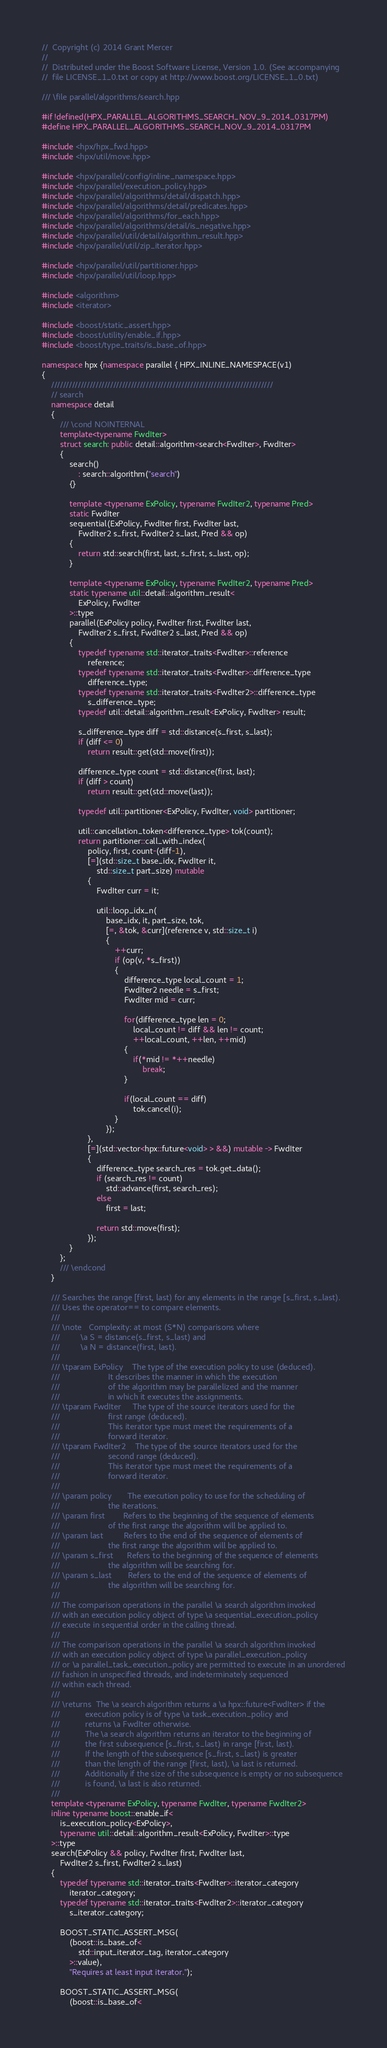<code> <loc_0><loc_0><loc_500><loc_500><_C++_>//  Copyright (c) 2014 Grant Mercer
//
//  Distributed under the Boost Software License, Version 1.0. (See accompanying
//  file LICENSE_1_0.txt or copy at http://www.boost.org/LICENSE_1_0.txt)

/// \file parallel/algorithms/search.hpp

#if !defined(HPX_PARALLEL_ALGORITHMS_SEARCH_NOV_9_2014_0317PM)
#define HPX_PARALLEL_ALGORITHMS_SEARCH_NOV_9_2014_0317PM

#include <hpx/hpx_fwd.hpp>
#include <hpx/util/move.hpp>

#include <hpx/parallel/config/inline_namespace.hpp>
#include <hpx/parallel/execution_policy.hpp>
#include <hpx/parallel/algorithms/detail/dispatch.hpp>
#include <hpx/parallel/algorithms/detail/predicates.hpp>
#include <hpx/parallel/algorithms/for_each.hpp>
#include <hpx/parallel/algorithms/detail/is_negative.hpp>
#include <hpx/parallel/util/detail/algorithm_result.hpp>
#include <hpx/parallel/util/zip_iterator.hpp>

#include <hpx/parallel/util/partitioner.hpp>
#include <hpx/parallel/util/loop.hpp>

#include <algorithm>
#include <iterator>

#include <boost/static_assert.hpp>
#include <boost/utility/enable_if.hpp>
#include <boost/type_traits/is_base_of.hpp>

namespace hpx {namespace parallel { HPX_INLINE_NAMESPACE(v1)
{
    ///////////////////////////////////////////////////////////////////////////
    // search
    namespace detail
    {
        /// \cond NOINTERNAL
        template<typename FwdIter>
        struct search: public detail::algorithm<search<FwdIter>, FwdIter>
        {
            search()
                : search::algorithm("search")
            {}

            template <typename ExPolicy, typename FwdIter2, typename Pred>
            static FwdIter
            sequential(ExPolicy, FwdIter first, FwdIter last,
                FwdIter2 s_first, FwdIter2 s_last, Pred && op)
            {
                return std::search(first, last, s_first, s_last, op);
            }

            template <typename ExPolicy, typename FwdIter2, typename Pred>
            static typename util::detail::algorithm_result<
                ExPolicy, FwdIter
            >::type
            parallel(ExPolicy policy, FwdIter first, FwdIter last,
                FwdIter2 s_first, FwdIter2 s_last, Pred && op)
            {
                typedef typename std::iterator_traits<FwdIter>::reference
                    reference;
                typedef typename std::iterator_traits<FwdIter>::difference_type
                    difference_type;
                typedef typename std::iterator_traits<FwdIter2>::difference_type
                    s_difference_type;
                typedef util::detail::algorithm_result<ExPolicy, FwdIter> result;

                s_difference_type diff = std::distance(s_first, s_last);
                if (diff <= 0)
                    return result::get(std::move(first));

                difference_type count = std::distance(first, last);
                if (diff > count)
                    return result::get(std::move(last));

                typedef util::partitioner<ExPolicy, FwdIter, void> partitioner;

                util::cancellation_token<difference_type> tok(count);
                return partitioner::call_with_index(
                    policy, first, count-(diff-1),
                    [=](std::size_t base_idx, FwdIter it,
                        std::size_t part_size) mutable
                    {
                        FwdIter curr = it;

                        util::loop_idx_n(
                            base_idx, it, part_size, tok,
                            [=, &tok, &curr](reference v, std::size_t i)
                            {
                                ++curr;
                                if (op(v, *s_first))
                                {
                                    difference_type local_count = 1;
                                    FwdIter2 needle = s_first;
                                    FwdIter mid = curr;

                                    for(difference_type len = 0;
                                        local_count != diff && len != count;
                                        ++local_count, ++len, ++mid)
                                    {
                                        if(*mid != *++needle)
                                            break;
                                    }

                                    if(local_count == diff)
                                        tok.cancel(i);
                                }
                            });
                    },
                    [=](std::vector<hpx::future<void> > &&) mutable -> FwdIter
                    {
                        difference_type search_res = tok.get_data();
                        if (search_res != count)
                            std::advance(first, search_res);
                        else
                            first = last;

                        return std::move(first);
                    });
            }
        };
        /// \endcond
    }

    /// Searches the range [first, last) for any elements in the range [s_first, s_last).
    /// Uses the operator== to compare elements.
    ///
    /// \note   Complexity: at most (S*N) comparisons where
    ///         \a S = distance(s_first, s_last) and
    ///         \a N = distance(first, last).
    ///
    /// \tparam ExPolicy    The type of the execution policy to use (deduced).
    ///                     It describes the manner in which the execution
    ///                     of the algorithm may be parallelized and the manner
    ///                     in which it executes the assignments.
    /// \tparam FwdIter     The type of the source iterators used for the
    ///                     first range (deduced).
    ///                     This iterator type must meet the requirements of a
    ///                     forward iterator.
    /// \tparam FwdIter2    The type of the source iterators used for the
    ///                     second range (deduced).
    ///                     This iterator type must meet the requirements of a
    ///                     forward iterator.
    ///
    /// \param policy       The execution policy to use for the scheduling of
    ///                     the iterations.
    /// \param first        Refers to the beginning of the sequence of elements
    ///                     of the first range the algorithm will be applied to.
    /// \param last         Refers to the end of the sequence of elements of
    ///                     the first range the algorithm will be applied to.
    /// \param s_first      Refers to the beginning of the sequence of elements
    ///                     the algorithm will be searching for.
    /// \param s_last       Refers to the end of the sequence of elements of
    ///                     the algorithm will be searching for.
    ///
    /// The comparison operations in the parallel \a search algorithm invoked
    /// with an execution policy object of type \a sequential_execution_policy
    /// execute in sequential order in the calling thread.
    ///
    /// The comparison operations in the parallel \a search algorithm invoked
    /// with an execution policy object of type \a parallel_execution_policy
    /// or \a parallel_task_execution_policy are permitted to execute in an unordered
    /// fashion in unspecified threads, and indeterminately sequenced
    /// within each thread.
    ///
    /// \returns  The \a search algorithm returns a \a hpx::future<FwdIter> if the
    ///           execution policy is of type \a task_execution_policy and
    ///           returns \a FwdIter otherwise.
    ///           The \a search algorithm returns an iterator to the beginning of
    ///           the first subsequence [s_first, s_last) in range [first, last).
    ///           If the length of the subsequence [s_first, s_last) is greater
    ///           than the length of the range [first, last), \a last is returned.
    ///           Additionally if the size of the subsequence is empty or no subsequence
    ///           is found, \a last is also returned.
    ///
    template <typename ExPolicy, typename FwdIter, typename FwdIter2>
    inline typename boost::enable_if<
        is_execution_policy<ExPolicy>,
        typename util::detail::algorithm_result<ExPolicy, FwdIter>::type
    >::type
    search(ExPolicy && policy, FwdIter first, FwdIter last,
        FwdIter2 s_first, FwdIter2 s_last)
    {
        typedef typename std::iterator_traits<FwdIter>::iterator_category
            iterator_category;
        typedef typename std::iterator_traits<FwdIter2>::iterator_category
            s_iterator_category;

        BOOST_STATIC_ASSERT_MSG(
            (boost::is_base_of<
                std::input_iterator_tag, iterator_category
            >::value),
            "Requires at least input iterator.");

        BOOST_STATIC_ASSERT_MSG(
            (boost::is_base_of<</code> 